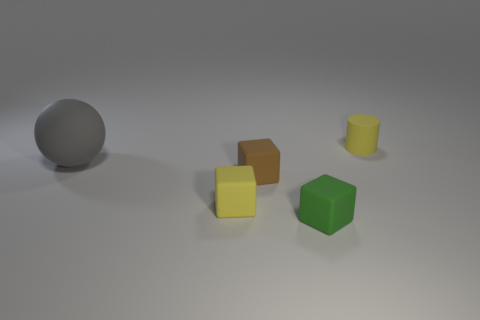What number of things are on the right side of the large rubber object and in front of the tiny cylinder?
Keep it short and to the point. 3. Are there fewer big rubber balls behind the yellow block than green matte things?
Give a very brief answer. No. Is there a purple cube that has the same size as the ball?
Ensure brevity in your answer.  No. What is the color of the cylinder that is the same material as the ball?
Offer a terse response. Yellow. There is a tiny yellow matte object in front of the big gray rubber ball; how many objects are right of it?
Offer a terse response. 3. What material is the object that is to the right of the brown matte object and in front of the cylinder?
Offer a very short reply. Rubber. Is the shape of the small yellow rubber object in front of the big ball the same as  the gray object?
Provide a succinct answer. No. Are there fewer small green matte cubes than small yellow things?
Your answer should be very brief. Yes. What number of rubber cubes have the same color as the rubber cylinder?
Keep it short and to the point. 1. What is the material of the object that is the same color as the small cylinder?
Provide a succinct answer. Rubber. 